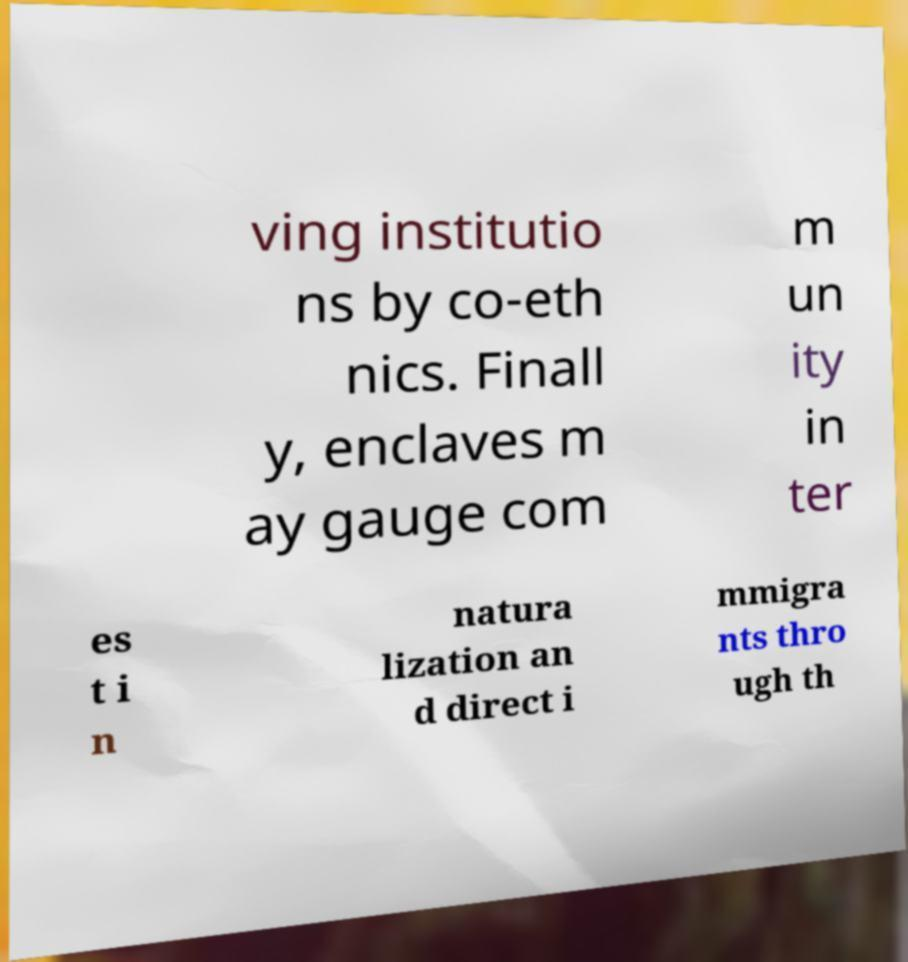What messages or text are displayed in this image? I need them in a readable, typed format. ving institutio ns by co-eth nics. Finall y, enclaves m ay gauge com m un ity in ter es t i n natura lization an d direct i mmigra nts thro ugh th 